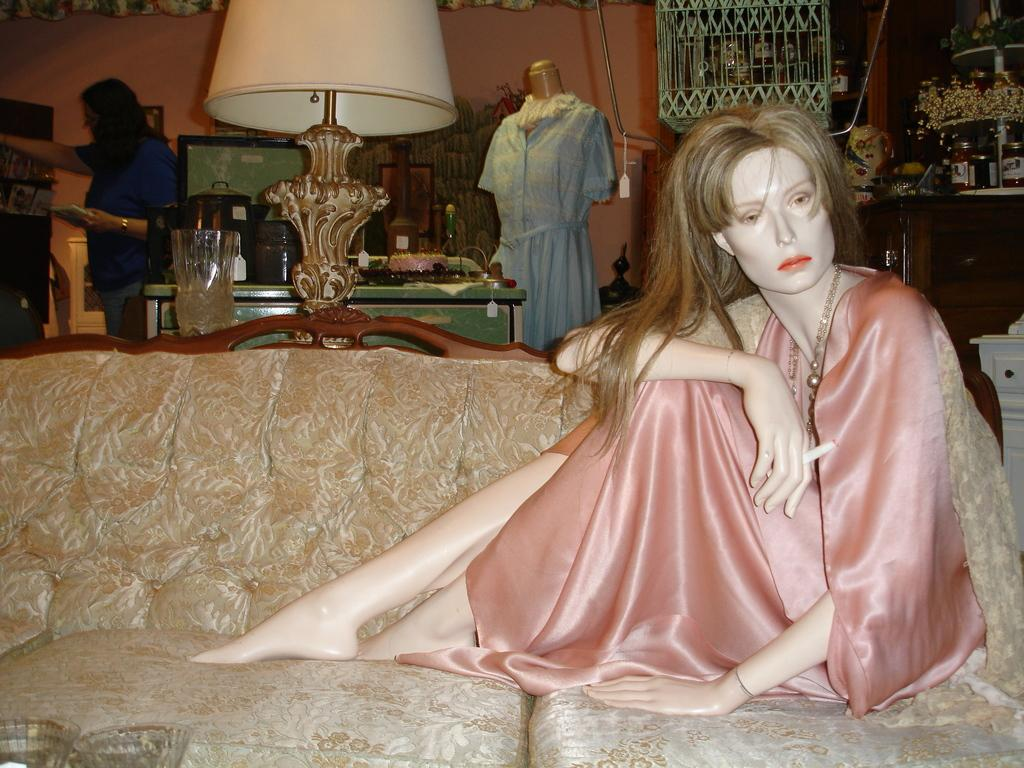What is placed on the sofa in the image? There is a statue or doll placed on the sofa. What can be seen in the background of the image? In the background of the image, there is a lamp, a dress, a woman, and some other unspecified objects. Can you describe the woman in the background of the image? The woman in the background of the image is not described in detail, but she is present. How many bears are visible in the image? There are no bears present in the image. What type of side dish is being served on the table in the image? There is no table or side dish present in the image. 